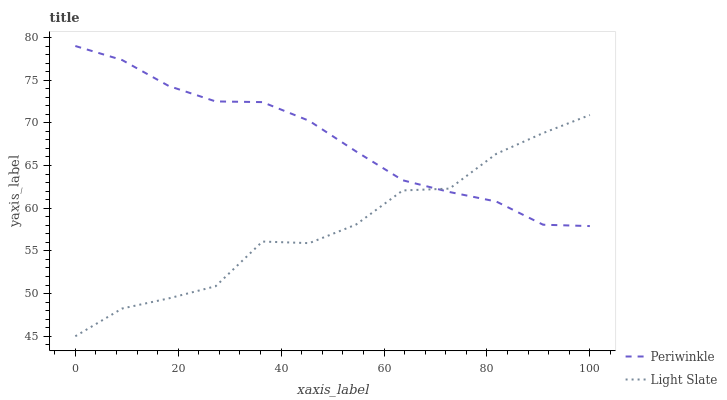Does Light Slate have the minimum area under the curve?
Answer yes or no. Yes. Does Periwinkle have the maximum area under the curve?
Answer yes or no. Yes. Does Periwinkle have the minimum area under the curve?
Answer yes or no. No. Is Periwinkle the smoothest?
Answer yes or no. Yes. Is Light Slate the roughest?
Answer yes or no. Yes. Is Periwinkle the roughest?
Answer yes or no. No. Does Periwinkle have the lowest value?
Answer yes or no. No. Does Periwinkle have the highest value?
Answer yes or no. Yes. 